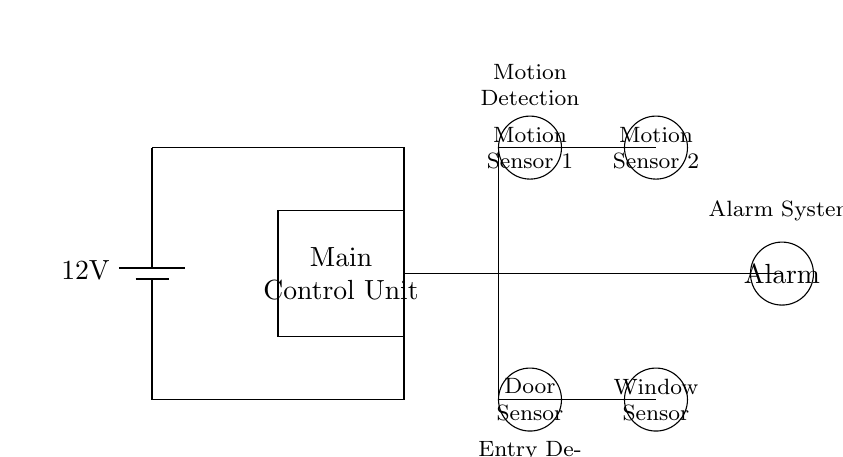What is the voltage of the power supply? The circuit shows a battery labeled with a voltage of 12V. This indicates the potential difference supplied by the power source.
Answer: 12V What does the Main Control Unit do? The Main Control Unit processes the signals from the sensors and determines if the alarm should be triggered. It acts as the central point for monitoring sensor input.
Answer: Control signals How many motion sensors are present in the circuit? The diagram includes two distinct circles labeled as Motion Sensor 1 and Motion Sensor 2, thus indicating that there are two motion sensors in total.
Answer: Two Which sensors are responsible for entry detection? The Door Sensor and Window Sensor are specifically designed for entry detection as they are located at the bottom of the diagram and labeled accordingly.
Answer: Door Sensor and Window Sensor What is the output component that activates when a sensor detects motion? The Alarm is the output component in the diagram that is triggered when any of the sensors detect activity, indicating potential intrusion.
Answer: Alarm How are the motion sensors connected to the Main Control Unit? The motion sensors are connected through a series of lines leading from the sensors to the Main Control Unit, showing that they send signals directly to it for processing.
Answer: Directly connected What happens after motion is detected by the sensors? When motion is detected, the signal is sent to the Main Control Unit, which can either trigger the alarm if unauthorized entry is confirmed.
Answer: Alarm triggers 